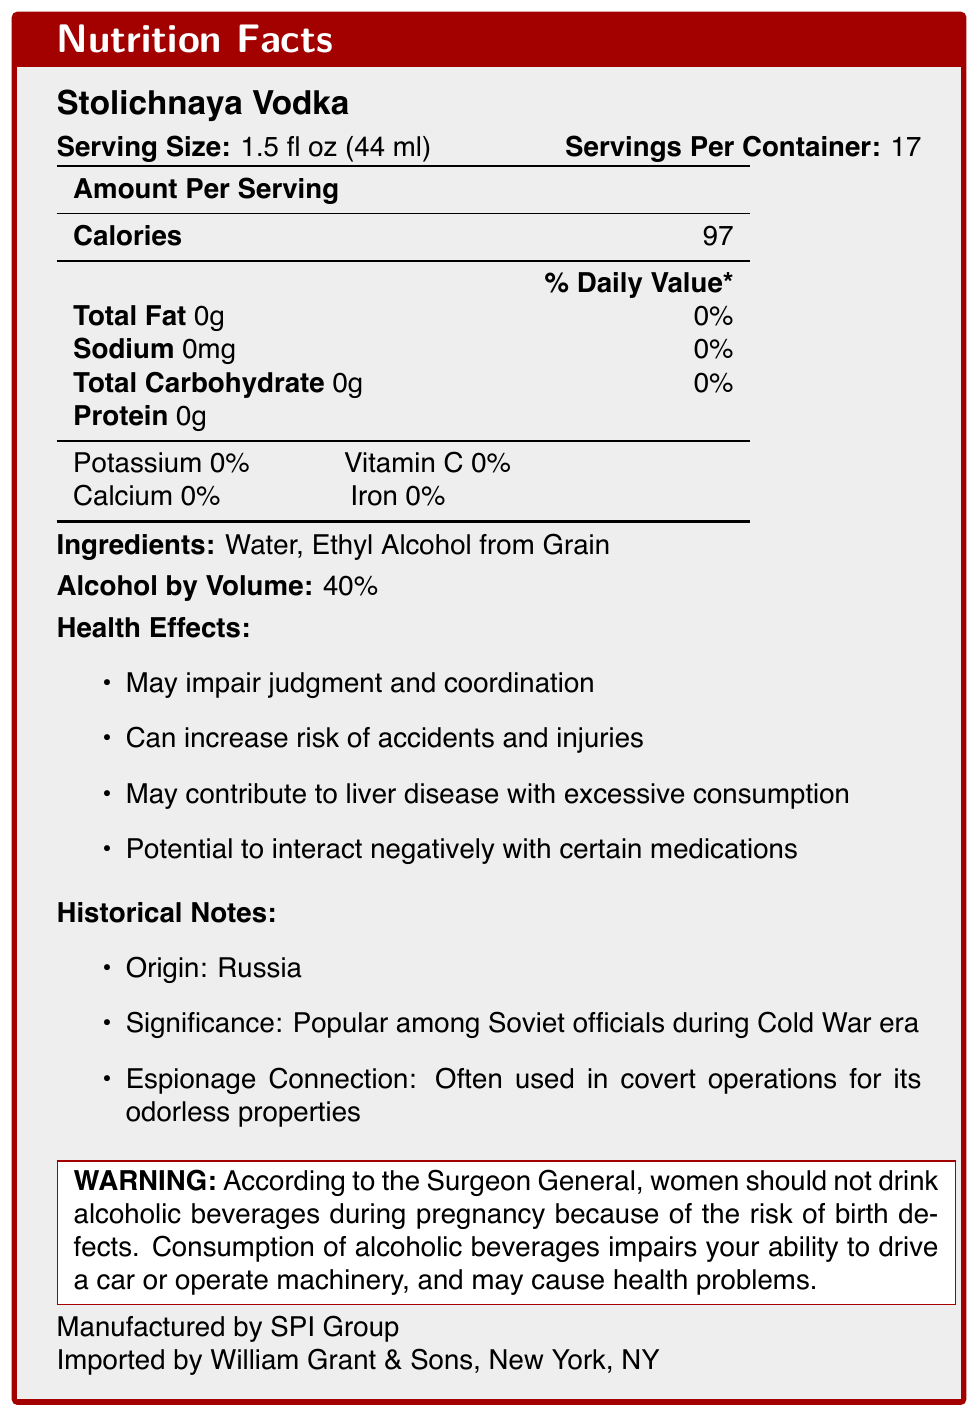what is the serving size? The document specifies that the serving size for Stolichnaya Vodka is 1.5 fluid ounces, which is equivalent to 44 milliliters.
Answer: 1.5 fl oz (44 ml) how many calories are in one serving? The nutrition facts section states that there are 97 calories in one serving of Stolichnaya Vodka.
Answer: 97 what are the ingredients in Stolichnaya Vodka? The ingredients listed in the document are Water and Ethyl Alcohol from Grain.
Answer: Water, Ethyl Alcohol from Grain what is the alcohol by volume percentage? The document states that the alcohol by volume (ABV) for Stolichnaya Vodka is 40%.
Answer: 40% how many servings are in one container? The document indicates that there are 17 servings per container of Stolichnaya Vodka.
Answer: 17 what are the potential health effects of consuming this product? The health effects listed in the document include impaired judgment and coordination, increased risk of accidents and injuries, potential liver disease with excessive consumption, and negative interactions with certain medications.
Answer: May impair judgment and coordination, Can increase risk of accidents and injuries, May contribute to liver disease with excessive consumption, Potential to interact negatively with certain medications what are the vitamin and mineral contents in the vodka? A. Potassium: 0%, Vitamin C: 0% B. Potassium: 5%, Vitamin C: 0% C. Potassium: 0%, Iron: 5% D. Calcium: 5%, Iron: 5% The vitamins and minerals section in the document lists Potassium at 0% and Vitamin C at 0%.
Answer: A. Potassium: 0%, Vitamin C: 0% which of the following originated in Russia and was popular among Soviet officials during the Cold War era? I. Stolichnaya Vodka II. Ethyl Alcohol from Grain III. William Grant & Sons The historical notes section of the document states that Stolichnaya Vodka originated in Russia and was popular among Soviet officials during the Cold War era.
Answer: I. Stolichnaya Vodka is it safe for pregnant women to consume this product? The warning in the document clearly specifies that according to the Surgeon General, women should not drink alcoholic beverages during pregnancy because of the risk of birth defects.
Answer: No summarize the main nutritional and health information provided in the document. The document provides detailed nutritional facts, ingredients, health warnings, and historical significance of Stolichnaya Vodka. It emphasizes the calorie content, lack of other nutrients, potential health risks, and historical notes about its usage during the Cold War.
Answer: Stolichnaya Vodka has a serving size of 1.5 fl oz (44 ml) with 97 calories per serving. It contains no fat, sodium, carbohydrates, or protein. The alcohol by volume is 40%. The health effects include impaired judgment, risk of accidents, liver disease, and interactions with medications. There is a warning against consumption during pregnancy, and it advises against driving or operating machinery after drinking. The vodka has historical significance stemming from its popularity during the Soviet era. who was the manufacturer of Stolichnaya Vodka? The bottom of the document lists the manufacturer as SPI Group.
Answer: SPI Group how much sodium is in one serving of Stolichnaya Vodka? The nutrition facts section states that there is 0mg of sodium in one serving of Stolichnaya Vodka.
Answer: 0mg what is the distribution company for this vodka in New York? The document mentions that the vodka is imported by William Grant & Sons, New York, NY.
Answer: William Grant & Sons does the document explain the process of how the vodka is made? The document does not provide details on the manufacturing process of Stolichnaya Vodka; it only lists the ingredients and manufacturer.
Answer: Not enough information 